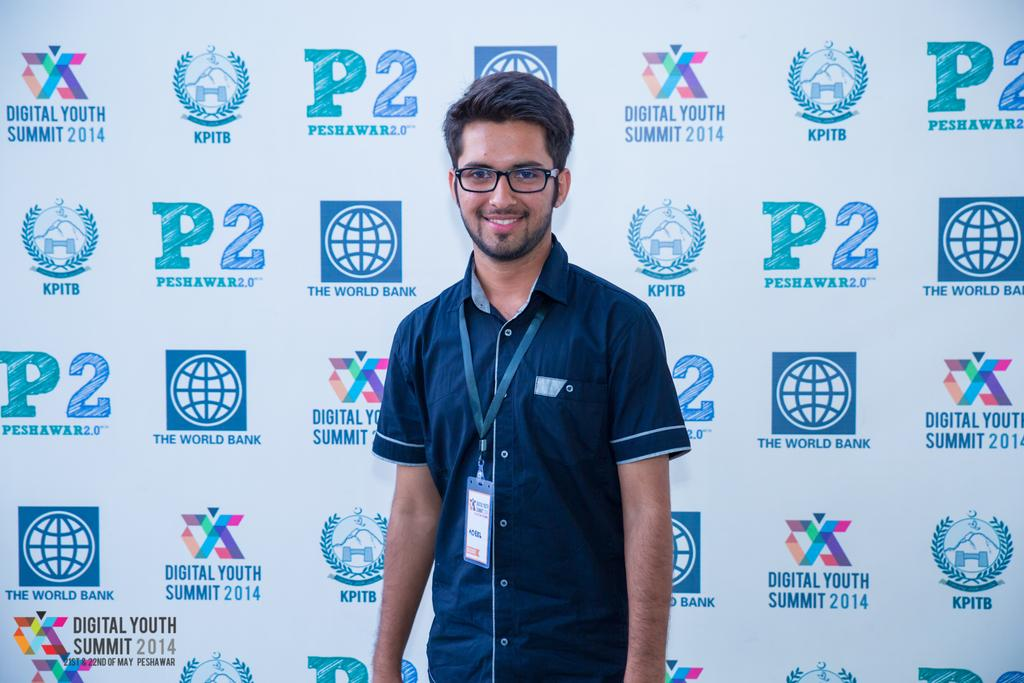What is the main subject of the image? There is a man standing in the center of the image. What is the man's facial expression? The man is smiling. What accessory is the man wearing? The man is wearing glasses. What can be seen in the background of the image? There is a board in the background of the image. Can you tell me how many tigers are present in the image? There are no tigers present in the image; it features a man standing in the center. What type of kitty is sitting on the man's shoulder in the image? There is no kitty present in the image; the man is standing alone. 